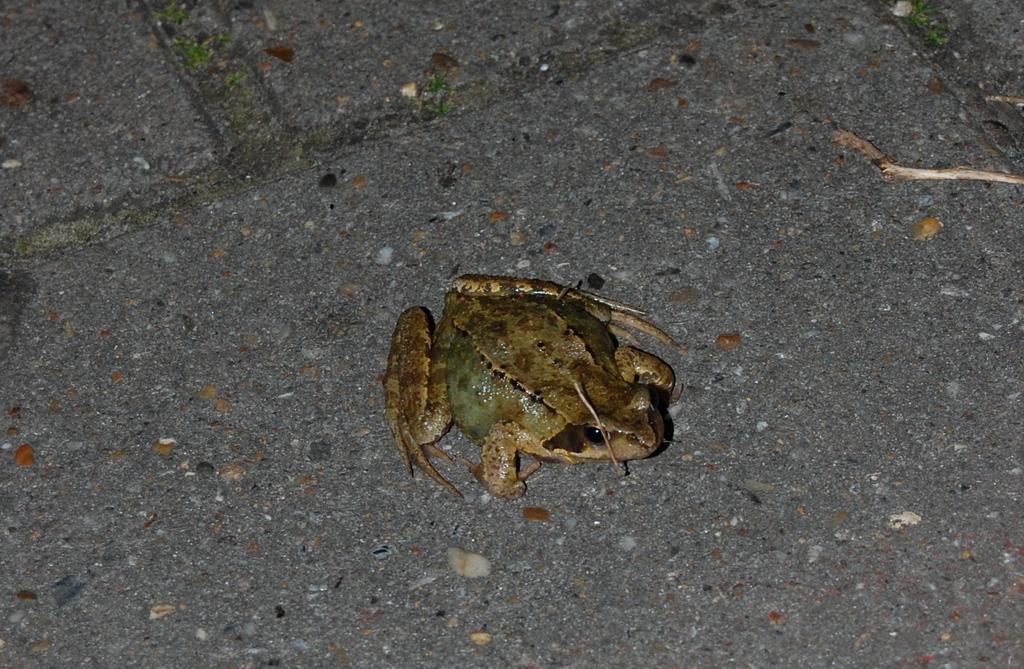How would you summarize this image in a sentence or two? In this image we can see a frog on the floor. 